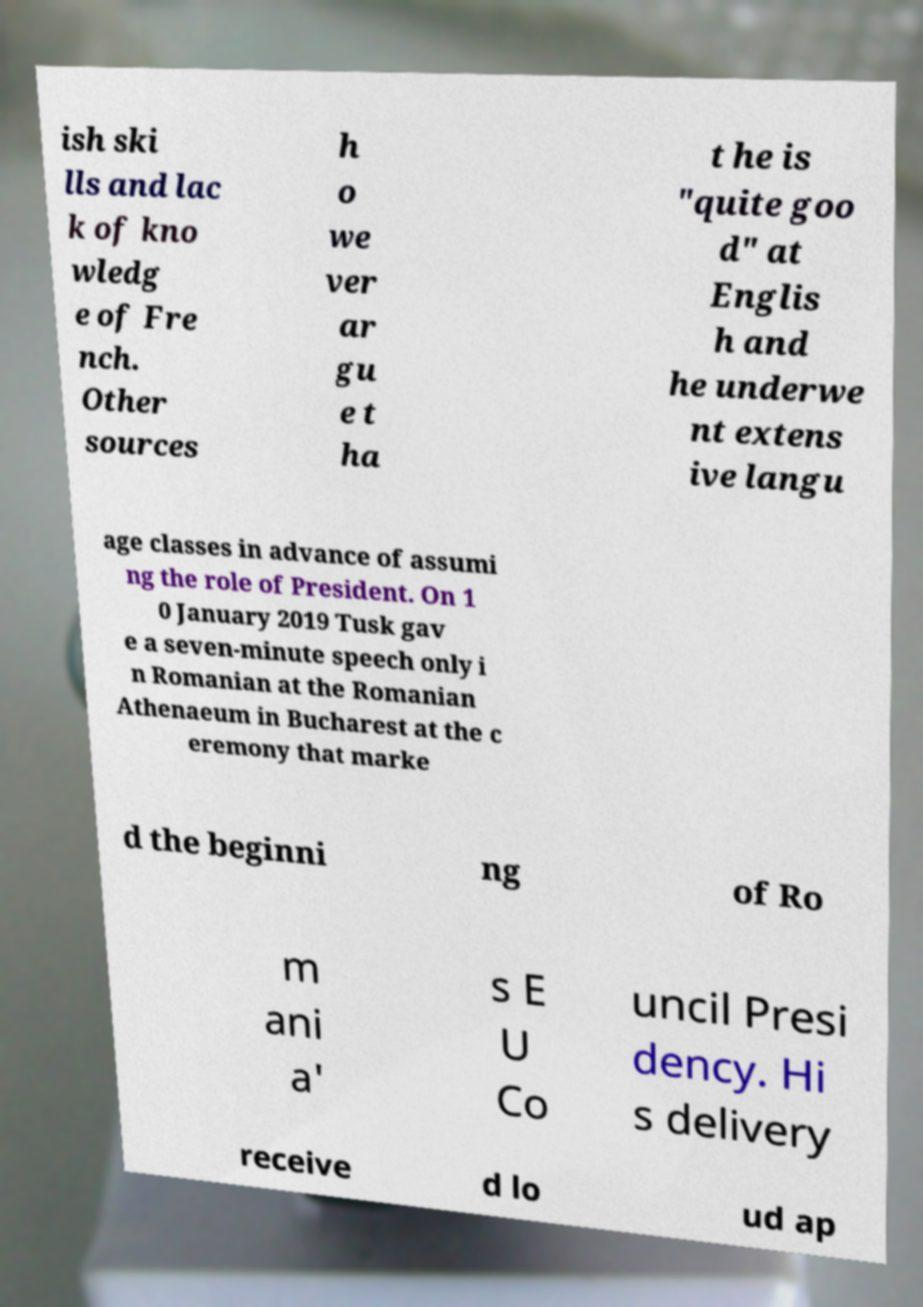Could you extract and type out the text from this image? ish ski lls and lac k of kno wledg e of Fre nch. Other sources h o we ver ar gu e t ha t he is "quite goo d" at Englis h and he underwe nt extens ive langu age classes in advance of assumi ng the role of President. On 1 0 January 2019 Tusk gav e a seven-minute speech only i n Romanian at the Romanian Athenaeum in Bucharest at the c eremony that marke d the beginni ng of Ro m ani a' s E U Co uncil Presi dency. Hi s delivery receive d lo ud ap 